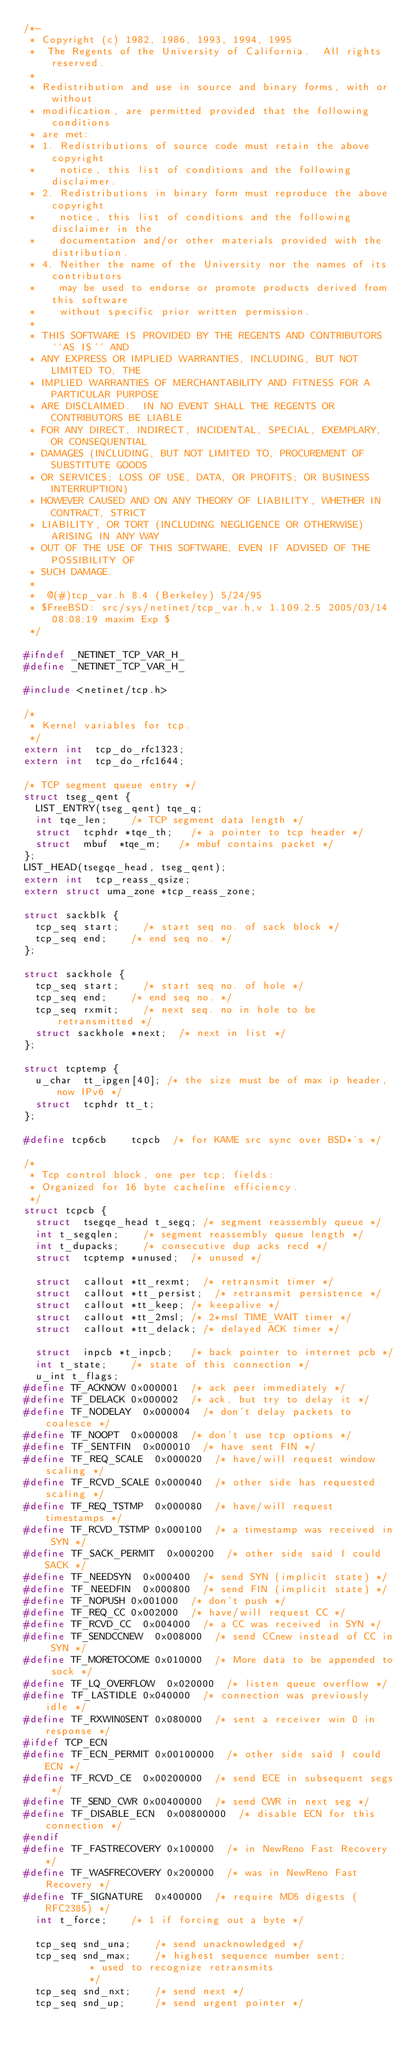Convert code to text. <code><loc_0><loc_0><loc_500><loc_500><_C_>/*-
 * Copyright (c) 1982, 1986, 1993, 1994, 1995
 *	The Regents of the University of California.  All rights reserved.
 *
 * Redistribution and use in source and binary forms, with or without
 * modification, are permitted provided that the following conditions
 * are met:
 * 1. Redistributions of source code must retain the above copyright
 *    notice, this list of conditions and the following disclaimer.
 * 2. Redistributions in binary form must reproduce the above copyright
 *    notice, this list of conditions and the following disclaimer in the
 *    documentation and/or other materials provided with the distribution.
 * 4. Neither the name of the University nor the names of its contributors
 *    may be used to endorse or promote products derived from this software
 *    without specific prior written permission.
 *
 * THIS SOFTWARE IS PROVIDED BY THE REGENTS AND CONTRIBUTORS ``AS IS'' AND
 * ANY EXPRESS OR IMPLIED WARRANTIES, INCLUDING, BUT NOT LIMITED TO, THE
 * IMPLIED WARRANTIES OF MERCHANTABILITY AND FITNESS FOR A PARTICULAR PURPOSE
 * ARE DISCLAIMED.  IN NO EVENT SHALL THE REGENTS OR CONTRIBUTORS BE LIABLE
 * FOR ANY DIRECT, INDIRECT, INCIDENTAL, SPECIAL, EXEMPLARY, OR CONSEQUENTIAL
 * DAMAGES (INCLUDING, BUT NOT LIMITED TO, PROCUREMENT OF SUBSTITUTE GOODS
 * OR SERVICES; LOSS OF USE, DATA, OR PROFITS; OR BUSINESS INTERRUPTION)
 * HOWEVER CAUSED AND ON ANY THEORY OF LIABILITY, WHETHER IN CONTRACT, STRICT
 * LIABILITY, OR TORT (INCLUDING NEGLIGENCE OR OTHERWISE) ARISING IN ANY WAY
 * OUT OF THE USE OF THIS SOFTWARE, EVEN IF ADVISED OF THE POSSIBILITY OF
 * SUCH DAMAGE.
 *
 *	@(#)tcp_var.h	8.4 (Berkeley) 5/24/95
 * $FreeBSD: src/sys/netinet/tcp_var.h,v 1.109.2.5 2005/03/14 08:08:19 maxim Exp $
 */

#ifndef _NETINET_TCP_VAR_H_
#define _NETINET_TCP_VAR_H_

#include <netinet/tcp.h>

/*
 * Kernel variables for tcp.
 */
extern int	tcp_do_rfc1323;
extern int	tcp_do_rfc1644;

/* TCP segment queue entry */
struct tseg_qent {
	LIST_ENTRY(tseg_qent) tqe_q;
	int	tqe_len;		/* TCP segment data length */
	struct	tcphdr *tqe_th;		/* a pointer to tcp header */
	struct	mbuf	*tqe_m;		/* mbuf contains packet */
};
LIST_HEAD(tsegqe_head, tseg_qent);
extern int	tcp_reass_qsize;
extern struct uma_zone *tcp_reass_zone;

struct sackblk {
	tcp_seq start;		/* start seq no. of sack block */
	tcp_seq end;		/* end seq no. */
};

struct sackhole {
	tcp_seq start;		/* start seq no. of hole */
	tcp_seq end;		/* end seq no. */
	tcp_seq rxmit;		/* next seq. no in hole to be retransmitted */
	struct sackhole *next;	/* next in list */
};

struct tcptemp {
	u_char	tt_ipgen[40]; /* the size must be of max ip header, now IPv6 */
	struct	tcphdr tt_t;
};

#define tcp6cb		tcpcb  /* for KAME src sync over BSD*'s */

/*
 * Tcp control block, one per tcp; fields:
 * Organized for 16 byte cacheline efficiency.
 */
struct tcpcb {
	struct	tsegqe_head t_segq;	/* segment reassembly queue */
	int	t_segqlen;		/* segment reassembly queue length */
	int	t_dupacks;		/* consecutive dup acks recd */
	struct	tcptemp	*unused;	/* unused */

	struct	callout *tt_rexmt;	/* retransmit timer */
	struct	callout *tt_persist;	/* retransmit persistence */
	struct	callout *tt_keep;	/* keepalive */
	struct	callout *tt_2msl;	/* 2*msl TIME_WAIT timer */
	struct	callout *tt_delack;	/* delayed ACK timer */

	struct	inpcb *t_inpcb;		/* back pointer to internet pcb */
	int	t_state;		/* state of this connection */
	u_int	t_flags;
#define	TF_ACKNOW	0x000001	/* ack peer immediately */
#define	TF_DELACK	0x000002	/* ack, but try to delay it */
#define	TF_NODELAY	0x000004	/* don't delay packets to coalesce */
#define	TF_NOOPT	0x000008	/* don't use tcp options */
#define	TF_SENTFIN	0x000010	/* have sent FIN */
#define	TF_REQ_SCALE	0x000020	/* have/will request window scaling */
#define	TF_RCVD_SCALE	0x000040	/* other side has requested scaling */
#define	TF_REQ_TSTMP	0x000080	/* have/will request timestamps */
#define	TF_RCVD_TSTMP	0x000100	/* a timestamp was received in SYN */
#define	TF_SACK_PERMIT	0x000200	/* other side said I could SACK */
#define	TF_NEEDSYN	0x000400	/* send SYN (implicit state) */
#define	TF_NEEDFIN	0x000800	/* send FIN (implicit state) */
#define	TF_NOPUSH	0x001000	/* don't push */
#define	TF_REQ_CC	0x002000	/* have/will request CC */
#define	TF_RCVD_CC	0x004000	/* a CC was received in SYN */
#define	TF_SENDCCNEW	0x008000	/* send CCnew instead of CC in SYN */
#define	TF_MORETOCOME	0x010000	/* More data to be appended to sock */
#define	TF_LQ_OVERFLOW	0x020000	/* listen queue overflow */
#define	TF_LASTIDLE	0x040000	/* connection was previously idle */
#define	TF_RXWIN0SENT	0x080000	/* sent a receiver win 0 in response */
#ifdef TCP_ECN
#define TF_ECN_PERMIT	0x00100000	/* other side said I could ECN */
#define TF_RCVD_CE	0x00200000	/* send ECE in subsequent segs */
#define TF_SEND_CWR	0x00400000	/* send CWR in next seg */
#define TF_DISABLE_ECN	0x00800000	/* disable ECN for this connection */
#endif
#define	TF_FASTRECOVERY	0x100000	/* in NewReno Fast Recovery */
#define	TF_WASFRECOVERY	0x200000	/* was in NewReno Fast Recovery */
#define	TF_SIGNATURE	0x400000	/* require MD5 digests (RFC2385) */
	int	t_force;		/* 1 if forcing out a byte */

	tcp_seq	snd_una;		/* send unacknowledged */
	tcp_seq	snd_max;		/* highest sequence number sent;
					 * used to recognize retransmits
					 */
	tcp_seq	snd_nxt;		/* send next */
	tcp_seq	snd_up;			/* send urgent pointer */
</code> 